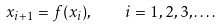<formula> <loc_0><loc_0><loc_500><loc_500>x _ { i + 1 } = f ( x _ { i } ) , \quad i = 1 , 2 , 3 , \dots .</formula> 